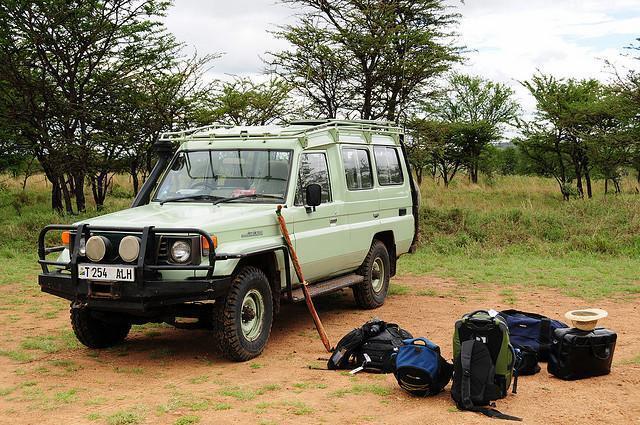What does the snorkel on the truck protect it from?
Pick the correct solution from the four options below to address the question.
Options: Fire, animals, dust, water. Water. 